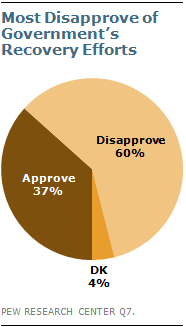Highlight a few significant elements in this photo. A majority of respondents, at 37%, approve of the government's efforts in the recovery process. In a dataset with values below 50, two segments that are similar in value may not have a significant difference. For example, if the value of segment 33 is compared to the value of segment 34, it is likely that their difference would be minimal since both segments have a value below 50. However, it is important to note that these segments may still have a difference that is worth considering, depending on the context and the specific values in question. 